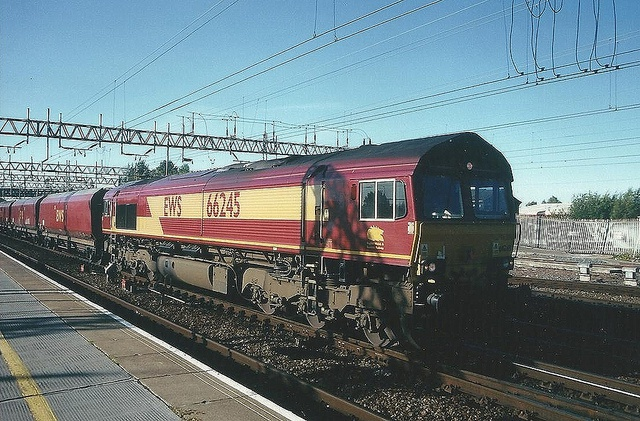Describe the objects in this image and their specific colors. I can see a train in gray, black, brown, and khaki tones in this image. 